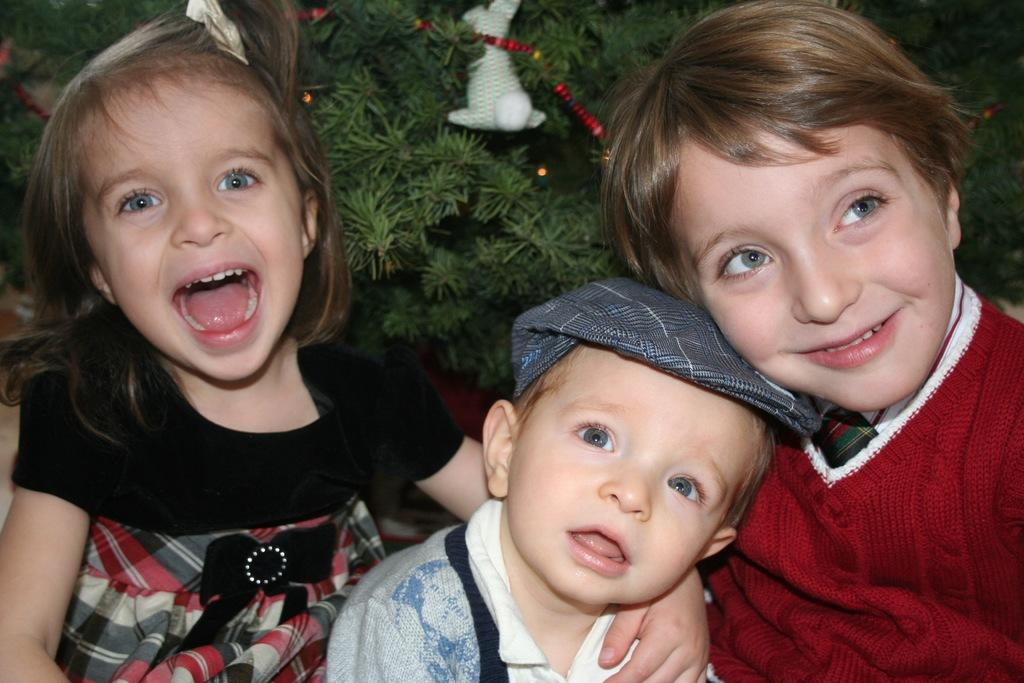How many kids are present in the image? There are three kids in the image. What is the facial expression of the kids? Two of the kids are smiling. What can be seen in the background of the image? There is a tree in the background of the image. Are there any decorations on the tree? Yes, the tree has some decorative items on it. What type of knowledge is being shared on the desk in the image? There is no desk present in the image, so knowledge sharing cannot be observed. 